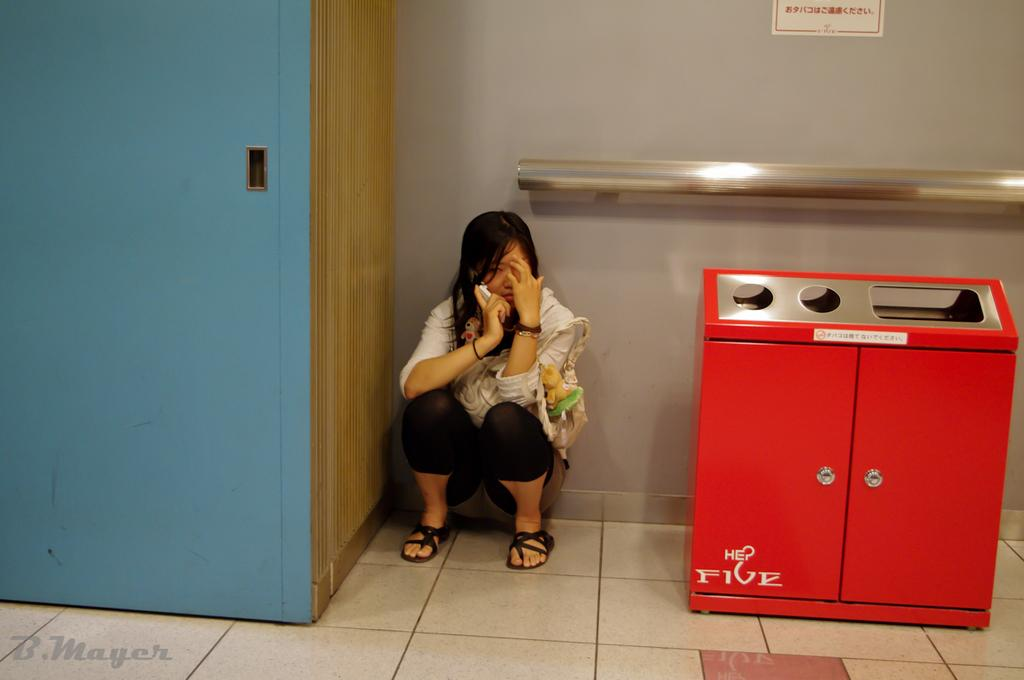<image>
Share a concise interpretation of the image provided. A woman on the foor between a blue cabinet and a red five machine. 